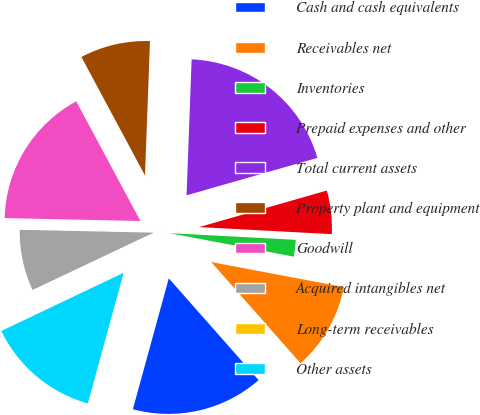<chart> <loc_0><loc_0><loc_500><loc_500><pie_chart><fcel>Cash and cash equivalents<fcel>Receivables net<fcel>Inventories<fcel>Prepaid expenses and other<fcel>Total current assets<fcel>Property plant and equipment<fcel>Goodwill<fcel>Acquired intangibles net<fcel>Long-term receivables<fcel>Other assets<nl><fcel>15.77%<fcel>10.52%<fcel>2.13%<fcel>5.28%<fcel>19.97%<fcel>8.43%<fcel>16.82%<fcel>7.38%<fcel>0.03%<fcel>13.67%<nl></chart> 